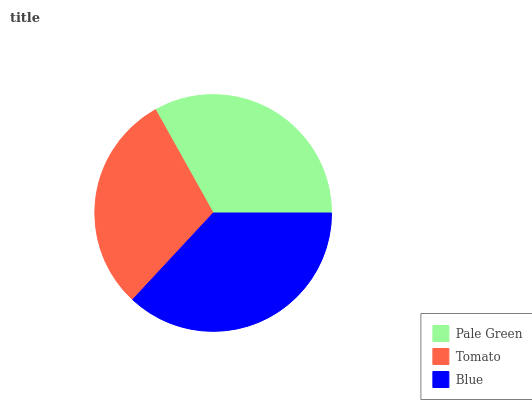Is Tomato the minimum?
Answer yes or no. Yes. Is Blue the maximum?
Answer yes or no. Yes. Is Blue the minimum?
Answer yes or no. No. Is Tomato the maximum?
Answer yes or no. No. Is Blue greater than Tomato?
Answer yes or no. Yes. Is Tomato less than Blue?
Answer yes or no. Yes. Is Tomato greater than Blue?
Answer yes or no. No. Is Blue less than Tomato?
Answer yes or no. No. Is Pale Green the high median?
Answer yes or no. Yes. Is Pale Green the low median?
Answer yes or no. Yes. Is Tomato the high median?
Answer yes or no. No. Is Tomato the low median?
Answer yes or no. No. 